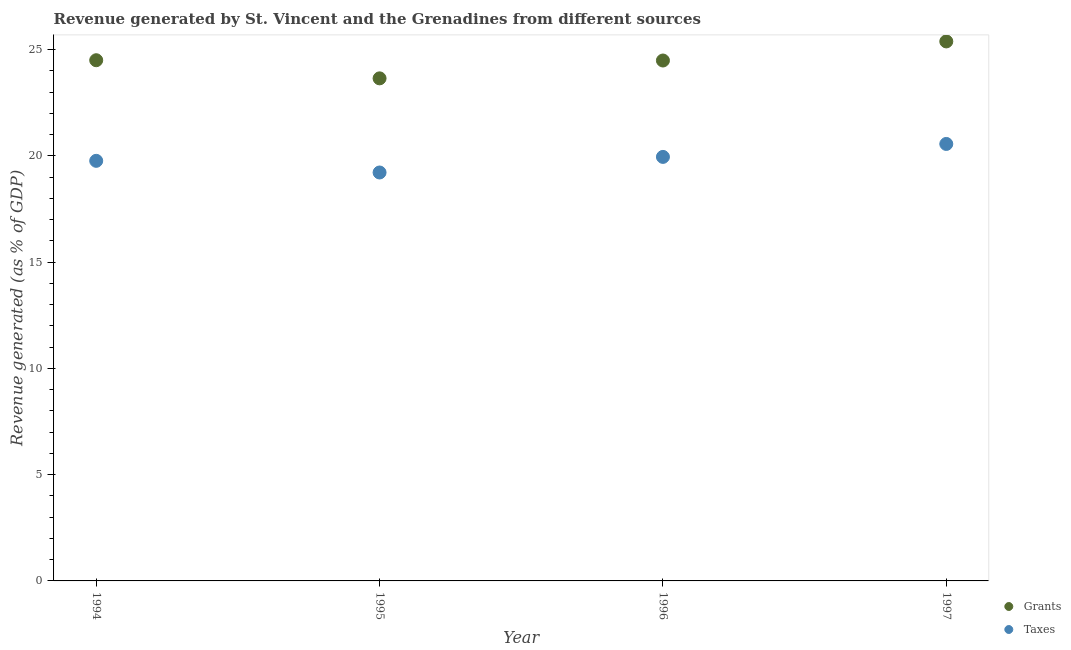What is the revenue generated by grants in 1994?
Ensure brevity in your answer.  24.5. Across all years, what is the maximum revenue generated by grants?
Give a very brief answer. 25.39. Across all years, what is the minimum revenue generated by grants?
Your answer should be very brief. 23.65. In which year was the revenue generated by taxes maximum?
Ensure brevity in your answer.  1997. What is the total revenue generated by taxes in the graph?
Your answer should be compact. 79.51. What is the difference between the revenue generated by taxes in 1994 and that in 1995?
Your answer should be very brief. 0.55. What is the difference between the revenue generated by grants in 1997 and the revenue generated by taxes in 1995?
Provide a short and direct response. 6.17. What is the average revenue generated by taxes per year?
Ensure brevity in your answer.  19.88. In the year 1995, what is the difference between the revenue generated by grants and revenue generated by taxes?
Make the answer very short. 4.43. What is the ratio of the revenue generated by grants in 1995 to that in 1997?
Provide a succinct answer. 0.93. Is the difference between the revenue generated by taxes in 1994 and 1996 greater than the difference between the revenue generated by grants in 1994 and 1996?
Make the answer very short. No. What is the difference between the highest and the second highest revenue generated by taxes?
Offer a terse response. 0.61. What is the difference between the highest and the lowest revenue generated by grants?
Ensure brevity in your answer.  1.74. In how many years, is the revenue generated by taxes greater than the average revenue generated by taxes taken over all years?
Make the answer very short. 2. Is the sum of the revenue generated by taxes in 1995 and 1996 greater than the maximum revenue generated by grants across all years?
Your answer should be compact. Yes. Does the revenue generated by grants monotonically increase over the years?
Provide a short and direct response. No. Is the revenue generated by grants strictly greater than the revenue generated by taxes over the years?
Give a very brief answer. Yes. Is the revenue generated by taxes strictly less than the revenue generated by grants over the years?
Ensure brevity in your answer.  Yes. What is the difference between two consecutive major ticks on the Y-axis?
Give a very brief answer. 5. Are the values on the major ticks of Y-axis written in scientific E-notation?
Make the answer very short. No. Does the graph contain any zero values?
Keep it short and to the point. No. How are the legend labels stacked?
Offer a terse response. Vertical. What is the title of the graph?
Give a very brief answer. Revenue generated by St. Vincent and the Grenadines from different sources. What is the label or title of the Y-axis?
Your answer should be compact. Revenue generated (as % of GDP). What is the Revenue generated (as % of GDP) of Grants in 1994?
Your answer should be very brief. 24.5. What is the Revenue generated (as % of GDP) of Taxes in 1994?
Offer a very short reply. 19.77. What is the Revenue generated (as % of GDP) of Grants in 1995?
Keep it short and to the point. 23.65. What is the Revenue generated (as % of GDP) in Taxes in 1995?
Make the answer very short. 19.22. What is the Revenue generated (as % of GDP) in Grants in 1996?
Make the answer very short. 24.49. What is the Revenue generated (as % of GDP) of Taxes in 1996?
Offer a very short reply. 19.95. What is the Revenue generated (as % of GDP) in Grants in 1997?
Ensure brevity in your answer.  25.39. What is the Revenue generated (as % of GDP) of Taxes in 1997?
Make the answer very short. 20.56. Across all years, what is the maximum Revenue generated (as % of GDP) in Grants?
Your answer should be compact. 25.39. Across all years, what is the maximum Revenue generated (as % of GDP) of Taxes?
Your answer should be very brief. 20.56. Across all years, what is the minimum Revenue generated (as % of GDP) of Grants?
Your answer should be compact. 23.65. Across all years, what is the minimum Revenue generated (as % of GDP) of Taxes?
Provide a succinct answer. 19.22. What is the total Revenue generated (as % of GDP) in Grants in the graph?
Your answer should be compact. 98.04. What is the total Revenue generated (as % of GDP) of Taxes in the graph?
Make the answer very short. 79.51. What is the difference between the Revenue generated (as % of GDP) in Grants in 1994 and that in 1995?
Make the answer very short. 0.85. What is the difference between the Revenue generated (as % of GDP) of Taxes in 1994 and that in 1995?
Your answer should be very brief. 0.55. What is the difference between the Revenue generated (as % of GDP) in Grants in 1994 and that in 1996?
Your answer should be very brief. 0.01. What is the difference between the Revenue generated (as % of GDP) of Taxes in 1994 and that in 1996?
Your answer should be very brief. -0.18. What is the difference between the Revenue generated (as % of GDP) in Grants in 1994 and that in 1997?
Ensure brevity in your answer.  -0.88. What is the difference between the Revenue generated (as % of GDP) in Taxes in 1994 and that in 1997?
Offer a terse response. -0.79. What is the difference between the Revenue generated (as % of GDP) of Grants in 1995 and that in 1996?
Offer a terse response. -0.84. What is the difference between the Revenue generated (as % of GDP) in Taxes in 1995 and that in 1996?
Keep it short and to the point. -0.73. What is the difference between the Revenue generated (as % of GDP) in Grants in 1995 and that in 1997?
Provide a succinct answer. -1.74. What is the difference between the Revenue generated (as % of GDP) in Taxes in 1995 and that in 1997?
Offer a terse response. -1.34. What is the difference between the Revenue generated (as % of GDP) of Grants in 1996 and that in 1997?
Offer a very short reply. -0.9. What is the difference between the Revenue generated (as % of GDP) of Taxes in 1996 and that in 1997?
Make the answer very short. -0.61. What is the difference between the Revenue generated (as % of GDP) of Grants in 1994 and the Revenue generated (as % of GDP) of Taxes in 1995?
Your answer should be very brief. 5.28. What is the difference between the Revenue generated (as % of GDP) in Grants in 1994 and the Revenue generated (as % of GDP) in Taxes in 1996?
Give a very brief answer. 4.55. What is the difference between the Revenue generated (as % of GDP) in Grants in 1994 and the Revenue generated (as % of GDP) in Taxes in 1997?
Offer a very short reply. 3.94. What is the difference between the Revenue generated (as % of GDP) in Grants in 1995 and the Revenue generated (as % of GDP) in Taxes in 1996?
Offer a very short reply. 3.7. What is the difference between the Revenue generated (as % of GDP) in Grants in 1995 and the Revenue generated (as % of GDP) in Taxes in 1997?
Your answer should be very brief. 3.09. What is the difference between the Revenue generated (as % of GDP) in Grants in 1996 and the Revenue generated (as % of GDP) in Taxes in 1997?
Give a very brief answer. 3.93. What is the average Revenue generated (as % of GDP) in Grants per year?
Make the answer very short. 24.51. What is the average Revenue generated (as % of GDP) of Taxes per year?
Keep it short and to the point. 19.88. In the year 1994, what is the difference between the Revenue generated (as % of GDP) of Grants and Revenue generated (as % of GDP) of Taxes?
Your response must be concise. 4.73. In the year 1995, what is the difference between the Revenue generated (as % of GDP) in Grants and Revenue generated (as % of GDP) in Taxes?
Make the answer very short. 4.43. In the year 1996, what is the difference between the Revenue generated (as % of GDP) of Grants and Revenue generated (as % of GDP) of Taxes?
Your answer should be compact. 4.54. In the year 1997, what is the difference between the Revenue generated (as % of GDP) in Grants and Revenue generated (as % of GDP) in Taxes?
Provide a short and direct response. 4.82. What is the ratio of the Revenue generated (as % of GDP) of Grants in 1994 to that in 1995?
Provide a short and direct response. 1.04. What is the ratio of the Revenue generated (as % of GDP) of Taxes in 1994 to that in 1995?
Offer a terse response. 1.03. What is the ratio of the Revenue generated (as % of GDP) in Grants in 1994 to that in 1996?
Give a very brief answer. 1. What is the ratio of the Revenue generated (as % of GDP) in Taxes in 1994 to that in 1996?
Provide a succinct answer. 0.99. What is the ratio of the Revenue generated (as % of GDP) of Grants in 1994 to that in 1997?
Offer a very short reply. 0.97. What is the ratio of the Revenue generated (as % of GDP) of Taxes in 1994 to that in 1997?
Your answer should be compact. 0.96. What is the ratio of the Revenue generated (as % of GDP) in Grants in 1995 to that in 1996?
Provide a short and direct response. 0.97. What is the ratio of the Revenue generated (as % of GDP) in Taxes in 1995 to that in 1996?
Make the answer very short. 0.96. What is the ratio of the Revenue generated (as % of GDP) of Grants in 1995 to that in 1997?
Offer a very short reply. 0.93. What is the ratio of the Revenue generated (as % of GDP) in Taxes in 1995 to that in 1997?
Offer a very short reply. 0.93. What is the ratio of the Revenue generated (as % of GDP) of Grants in 1996 to that in 1997?
Your answer should be compact. 0.96. What is the ratio of the Revenue generated (as % of GDP) of Taxes in 1996 to that in 1997?
Your answer should be very brief. 0.97. What is the difference between the highest and the second highest Revenue generated (as % of GDP) of Grants?
Ensure brevity in your answer.  0.88. What is the difference between the highest and the second highest Revenue generated (as % of GDP) of Taxes?
Ensure brevity in your answer.  0.61. What is the difference between the highest and the lowest Revenue generated (as % of GDP) in Grants?
Offer a terse response. 1.74. What is the difference between the highest and the lowest Revenue generated (as % of GDP) in Taxes?
Keep it short and to the point. 1.34. 